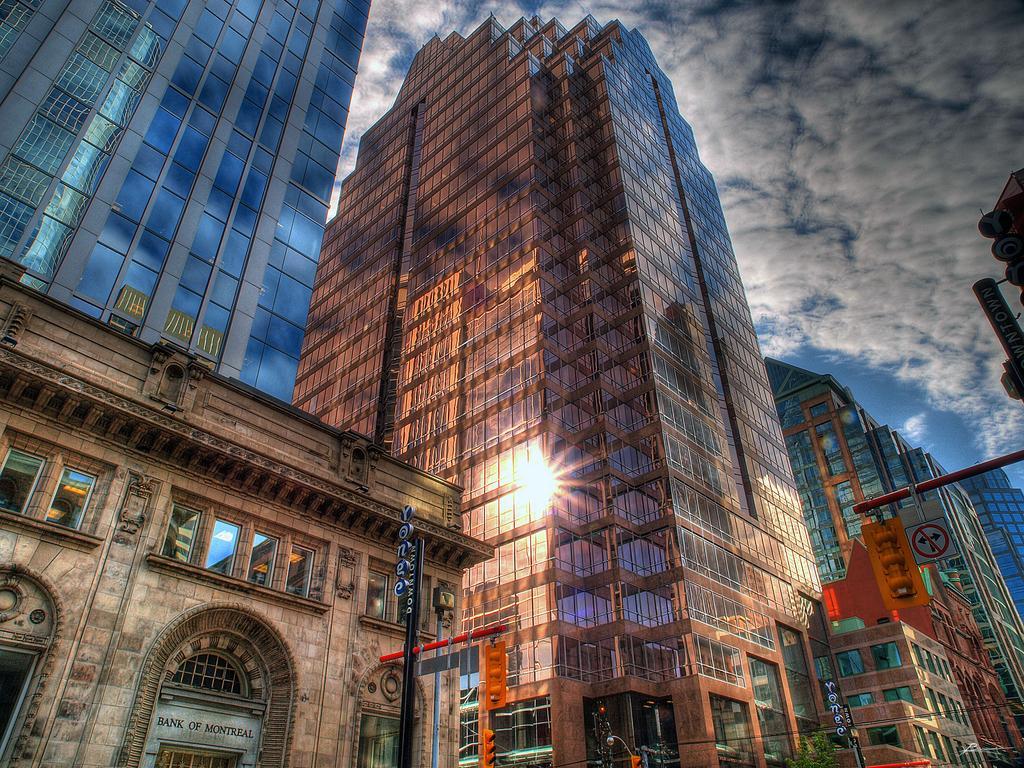How would you summarize this image in a sentence or two? In this image there are buildings and poles. We can see traffic lights. In the background there is sky. 